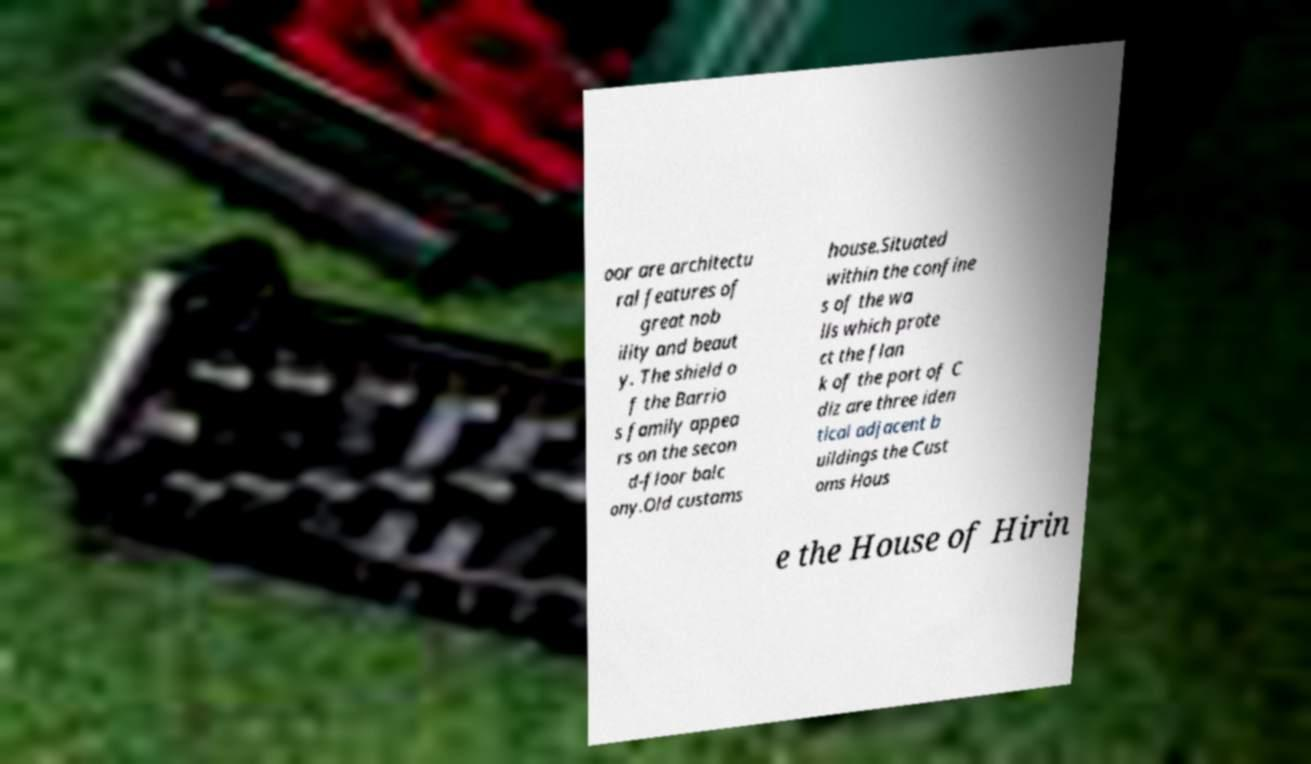Please read and relay the text visible in this image. What does it say? oor are architectu ral features of great nob ility and beaut y. The shield o f the Barrio s family appea rs on the secon d-floor balc ony.Old customs house.Situated within the confine s of the wa lls which prote ct the flan k of the port of C diz are three iden tical adjacent b uildings the Cust oms Hous e the House of Hirin 